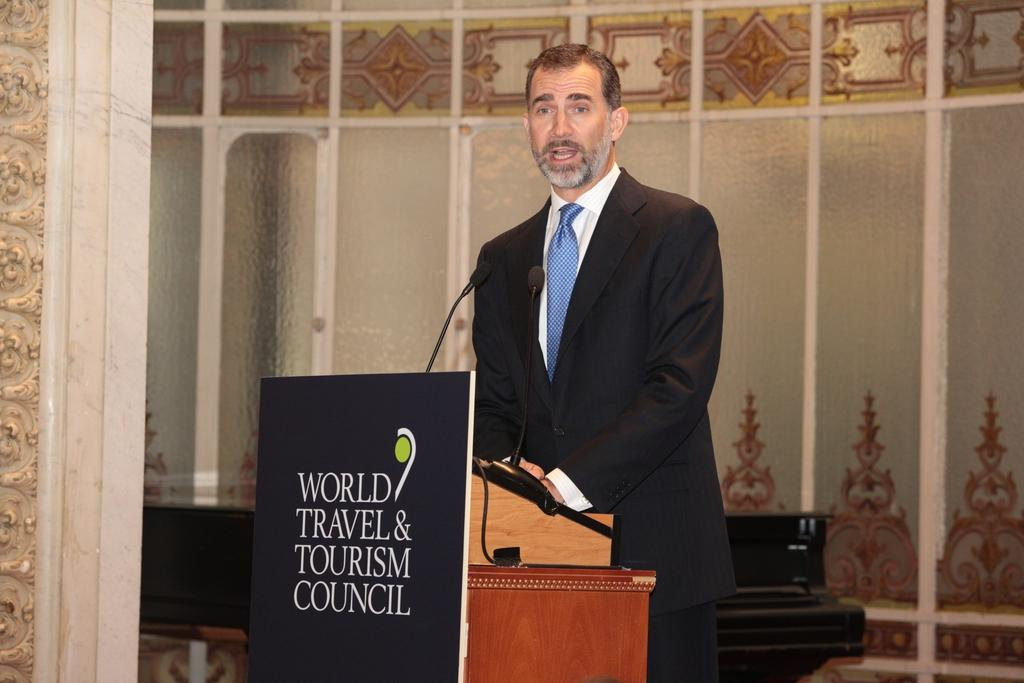Who is in the image? There is a person in the image. What is the person wearing? The person is wearing a coat and tie. What is the person standing in front of? The person is standing in front of a podium. What is on the podium? Two microphones are placed on the podium. What can be seen in the background of the image? There is a piano in the background of the image. How many babies are visible in the image? There are no babies present in the image. What is the amount of toothpaste used by the person in the image? There is no toothpaste mentioned or visible in the image. 